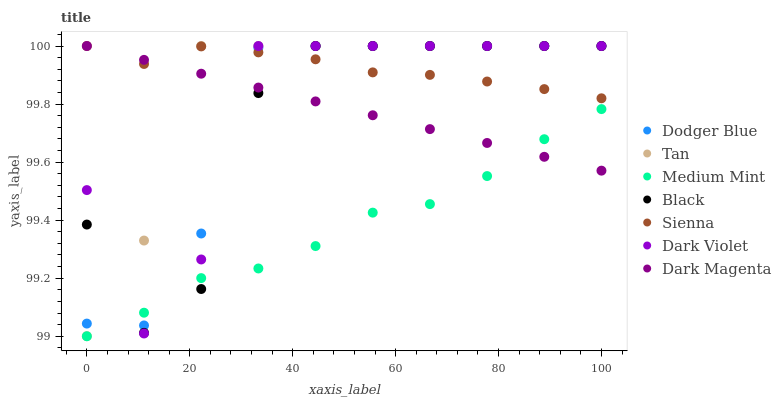Does Medium Mint have the minimum area under the curve?
Answer yes or no. Yes. Does Sienna have the maximum area under the curve?
Answer yes or no. Yes. Does Dark Magenta have the minimum area under the curve?
Answer yes or no. No. Does Dark Magenta have the maximum area under the curve?
Answer yes or no. No. Is Dark Magenta the smoothest?
Answer yes or no. Yes. Is Dark Violet the roughest?
Answer yes or no. Yes. Is Dark Violet the smoothest?
Answer yes or no. No. Is Dark Magenta the roughest?
Answer yes or no. No. Does Medium Mint have the lowest value?
Answer yes or no. Yes. Does Dark Magenta have the lowest value?
Answer yes or no. No. Does Tan have the highest value?
Answer yes or no. Yes. Is Medium Mint less than Sienna?
Answer yes or no. Yes. Is Sienna greater than Medium Mint?
Answer yes or no. Yes. Does Dodger Blue intersect Dark Magenta?
Answer yes or no. Yes. Is Dodger Blue less than Dark Magenta?
Answer yes or no. No. Is Dodger Blue greater than Dark Magenta?
Answer yes or no. No. Does Medium Mint intersect Sienna?
Answer yes or no. No. 